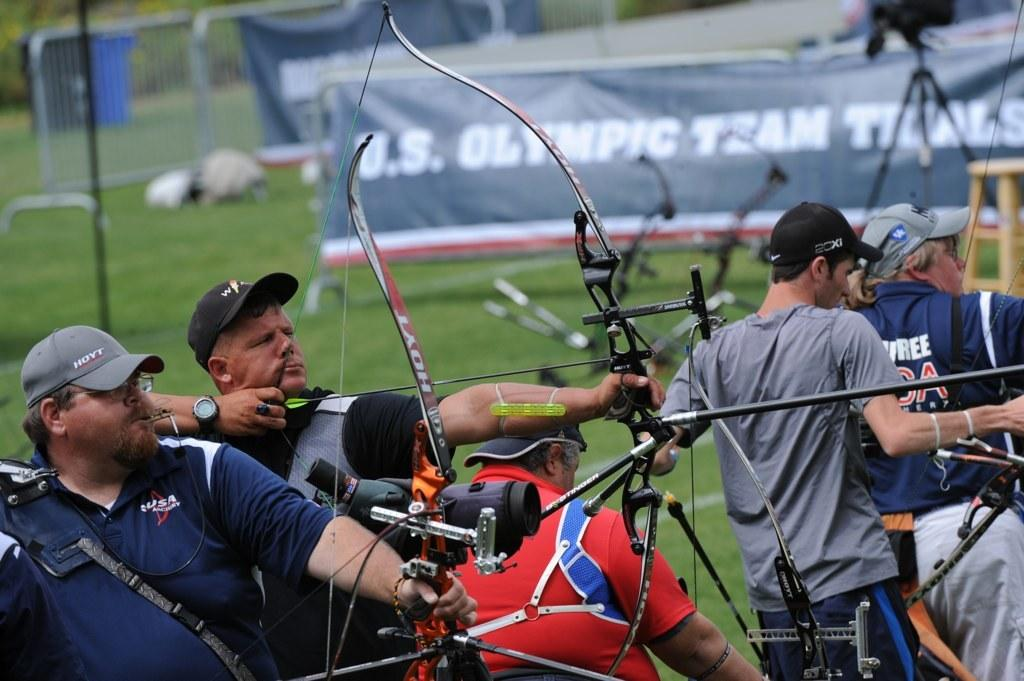What are the people in the image holding? The people in the image are holding bows and arrows. What equipment is set up for capturing images in the image? There is a camera with a tripod stand in the image. What type of seating is present in the image? There is a stool in the image. What type of signage is visible in the image? There are banners in the image. What type of barriers are present in the image? There are barriers in the image. What type of ground surface is visible in the image? There is grass in the image. Reasoning: Let'g: Let's think step by step in order to produce the conversation. We start by identifying the main subjects in the image, which are the group of people holding bows and arrows. Then, we expand the conversation to include other items that are also visible, such as the camera, stool, banners, barriers, and grass. Each question is designed to elicit a specific detail about the image that is known from the provided facts. Absurd Question/Answer: How many girls are seen playing with the brake in the image? There is no brake or girls present in the image. What type of waste is being disposed of in the image? There is no waste disposal visible in the image. 